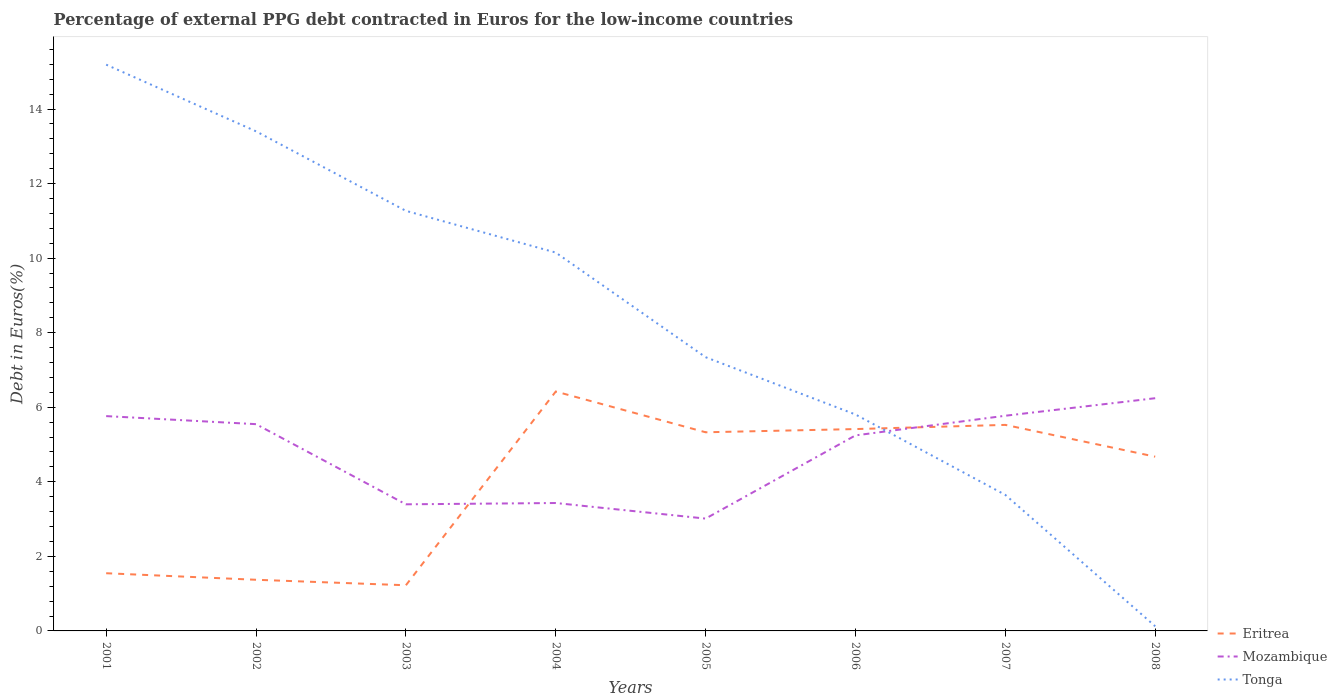Is the number of lines equal to the number of legend labels?
Your answer should be compact. Yes. Across all years, what is the maximum percentage of external PPG debt contracted in Euros in Tonga?
Your answer should be very brief. 0.12. What is the total percentage of external PPG debt contracted in Euros in Mozambique in the graph?
Your answer should be compact. -3.23. What is the difference between the highest and the second highest percentage of external PPG debt contracted in Euros in Tonga?
Make the answer very short. 15.07. Is the percentage of external PPG debt contracted in Euros in Tonga strictly greater than the percentage of external PPG debt contracted in Euros in Mozambique over the years?
Give a very brief answer. No. How many lines are there?
Make the answer very short. 3. What is the difference between two consecutive major ticks on the Y-axis?
Provide a succinct answer. 2. Are the values on the major ticks of Y-axis written in scientific E-notation?
Offer a very short reply. No. Does the graph contain any zero values?
Offer a very short reply. No. How many legend labels are there?
Provide a short and direct response. 3. How are the legend labels stacked?
Your answer should be compact. Vertical. What is the title of the graph?
Provide a short and direct response. Percentage of external PPG debt contracted in Euros for the low-income countries. Does "Serbia" appear as one of the legend labels in the graph?
Your answer should be compact. No. What is the label or title of the X-axis?
Your response must be concise. Years. What is the label or title of the Y-axis?
Your answer should be compact. Debt in Euros(%). What is the Debt in Euros(%) of Eritrea in 2001?
Keep it short and to the point. 1.55. What is the Debt in Euros(%) in Mozambique in 2001?
Make the answer very short. 5.76. What is the Debt in Euros(%) of Tonga in 2001?
Offer a very short reply. 15.19. What is the Debt in Euros(%) of Eritrea in 2002?
Give a very brief answer. 1.37. What is the Debt in Euros(%) of Mozambique in 2002?
Your answer should be compact. 5.55. What is the Debt in Euros(%) in Tonga in 2002?
Your answer should be compact. 13.4. What is the Debt in Euros(%) in Eritrea in 2003?
Ensure brevity in your answer.  1.23. What is the Debt in Euros(%) of Mozambique in 2003?
Keep it short and to the point. 3.4. What is the Debt in Euros(%) of Tonga in 2003?
Give a very brief answer. 11.27. What is the Debt in Euros(%) of Eritrea in 2004?
Offer a very short reply. 6.42. What is the Debt in Euros(%) in Mozambique in 2004?
Your response must be concise. 3.43. What is the Debt in Euros(%) of Tonga in 2004?
Provide a succinct answer. 10.15. What is the Debt in Euros(%) of Eritrea in 2005?
Make the answer very short. 5.33. What is the Debt in Euros(%) in Mozambique in 2005?
Give a very brief answer. 3.01. What is the Debt in Euros(%) of Tonga in 2005?
Your response must be concise. 7.34. What is the Debt in Euros(%) of Eritrea in 2006?
Make the answer very short. 5.41. What is the Debt in Euros(%) of Mozambique in 2006?
Your answer should be very brief. 5.25. What is the Debt in Euros(%) of Tonga in 2006?
Make the answer very short. 5.81. What is the Debt in Euros(%) of Eritrea in 2007?
Ensure brevity in your answer.  5.53. What is the Debt in Euros(%) in Mozambique in 2007?
Offer a very short reply. 5.77. What is the Debt in Euros(%) in Tonga in 2007?
Your response must be concise. 3.65. What is the Debt in Euros(%) in Eritrea in 2008?
Give a very brief answer. 4.67. What is the Debt in Euros(%) in Mozambique in 2008?
Keep it short and to the point. 6.24. What is the Debt in Euros(%) of Tonga in 2008?
Offer a very short reply. 0.12. Across all years, what is the maximum Debt in Euros(%) in Eritrea?
Your answer should be compact. 6.42. Across all years, what is the maximum Debt in Euros(%) in Mozambique?
Keep it short and to the point. 6.24. Across all years, what is the maximum Debt in Euros(%) of Tonga?
Your response must be concise. 15.19. Across all years, what is the minimum Debt in Euros(%) in Eritrea?
Your answer should be very brief. 1.23. Across all years, what is the minimum Debt in Euros(%) in Mozambique?
Give a very brief answer. 3.01. Across all years, what is the minimum Debt in Euros(%) in Tonga?
Ensure brevity in your answer.  0.12. What is the total Debt in Euros(%) of Eritrea in the graph?
Ensure brevity in your answer.  31.51. What is the total Debt in Euros(%) in Mozambique in the graph?
Make the answer very short. 38.41. What is the total Debt in Euros(%) in Tonga in the graph?
Ensure brevity in your answer.  66.93. What is the difference between the Debt in Euros(%) in Eritrea in 2001 and that in 2002?
Give a very brief answer. 0.18. What is the difference between the Debt in Euros(%) of Mozambique in 2001 and that in 2002?
Your answer should be compact. 0.22. What is the difference between the Debt in Euros(%) in Tonga in 2001 and that in 2002?
Provide a short and direct response. 1.79. What is the difference between the Debt in Euros(%) of Eritrea in 2001 and that in 2003?
Make the answer very short. 0.32. What is the difference between the Debt in Euros(%) of Mozambique in 2001 and that in 2003?
Give a very brief answer. 2.37. What is the difference between the Debt in Euros(%) of Tonga in 2001 and that in 2003?
Make the answer very short. 3.92. What is the difference between the Debt in Euros(%) in Eritrea in 2001 and that in 2004?
Ensure brevity in your answer.  -4.87. What is the difference between the Debt in Euros(%) in Mozambique in 2001 and that in 2004?
Your answer should be very brief. 2.33. What is the difference between the Debt in Euros(%) of Tonga in 2001 and that in 2004?
Your answer should be compact. 5.04. What is the difference between the Debt in Euros(%) in Eritrea in 2001 and that in 2005?
Provide a succinct answer. -3.78. What is the difference between the Debt in Euros(%) in Mozambique in 2001 and that in 2005?
Your answer should be very brief. 2.75. What is the difference between the Debt in Euros(%) of Tonga in 2001 and that in 2005?
Give a very brief answer. 7.85. What is the difference between the Debt in Euros(%) of Eritrea in 2001 and that in 2006?
Your answer should be very brief. -3.87. What is the difference between the Debt in Euros(%) in Mozambique in 2001 and that in 2006?
Your answer should be very brief. 0.52. What is the difference between the Debt in Euros(%) of Tonga in 2001 and that in 2006?
Provide a short and direct response. 9.38. What is the difference between the Debt in Euros(%) in Eritrea in 2001 and that in 2007?
Offer a terse response. -3.98. What is the difference between the Debt in Euros(%) in Mozambique in 2001 and that in 2007?
Your answer should be compact. -0.01. What is the difference between the Debt in Euros(%) in Tonga in 2001 and that in 2007?
Provide a succinct answer. 11.54. What is the difference between the Debt in Euros(%) in Eritrea in 2001 and that in 2008?
Offer a terse response. -3.13. What is the difference between the Debt in Euros(%) in Mozambique in 2001 and that in 2008?
Make the answer very short. -0.48. What is the difference between the Debt in Euros(%) in Tonga in 2001 and that in 2008?
Your answer should be very brief. 15.07. What is the difference between the Debt in Euros(%) of Eritrea in 2002 and that in 2003?
Your answer should be compact. 0.15. What is the difference between the Debt in Euros(%) of Mozambique in 2002 and that in 2003?
Make the answer very short. 2.15. What is the difference between the Debt in Euros(%) in Tonga in 2002 and that in 2003?
Your answer should be very brief. 2.13. What is the difference between the Debt in Euros(%) in Eritrea in 2002 and that in 2004?
Keep it short and to the point. -5.05. What is the difference between the Debt in Euros(%) in Mozambique in 2002 and that in 2004?
Offer a very short reply. 2.12. What is the difference between the Debt in Euros(%) in Tonga in 2002 and that in 2004?
Keep it short and to the point. 3.25. What is the difference between the Debt in Euros(%) of Eritrea in 2002 and that in 2005?
Offer a very short reply. -3.96. What is the difference between the Debt in Euros(%) in Mozambique in 2002 and that in 2005?
Your response must be concise. 2.53. What is the difference between the Debt in Euros(%) in Tonga in 2002 and that in 2005?
Your response must be concise. 6.06. What is the difference between the Debt in Euros(%) in Eritrea in 2002 and that in 2006?
Provide a short and direct response. -4.04. What is the difference between the Debt in Euros(%) in Mozambique in 2002 and that in 2006?
Give a very brief answer. 0.3. What is the difference between the Debt in Euros(%) of Tonga in 2002 and that in 2006?
Your answer should be compact. 7.6. What is the difference between the Debt in Euros(%) in Eritrea in 2002 and that in 2007?
Make the answer very short. -4.15. What is the difference between the Debt in Euros(%) of Mozambique in 2002 and that in 2007?
Provide a succinct answer. -0.23. What is the difference between the Debt in Euros(%) of Tonga in 2002 and that in 2007?
Make the answer very short. 9.75. What is the difference between the Debt in Euros(%) of Eritrea in 2002 and that in 2008?
Your answer should be very brief. -3.3. What is the difference between the Debt in Euros(%) of Mozambique in 2002 and that in 2008?
Ensure brevity in your answer.  -0.7. What is the difference between the Debt in Euros(%) of Tonga in 2002 and that in 2008?
Ensure brevity in your answer.  13.28. What is the difference between the Debt in Euros(%) in Eritrea in 2003 and that in 2004?
Your answer should be very brief. -5.2. What is the difference between the Debt in Euros(%) of Mozambique in 2003 and that in 2004?
Give a very brief answer. -0.04. What is the difference between the Debt in Euros(%) in Tonga in 2003 and that in 2004?
Your answer should be compact. 1.12. What is the difference between the Debt in Euros(%) in Eritrea in 2003 and that in 2005?
Provide a short and direct response. -4.1. What is the difference between the Debt in Euros(%) in Mozambique in 2003 and that in 2005?
Your answer should be compact. 0.38. What is the difference between the Debt in Euros(%) of Tonga in 2003 and that in 2005?
Give a very brief answer. 3.93. What is the difference between the Debt in Euros(%) in Eritrea in 2003 and that in 2006?
Ensure brevity in your answer.  -4.19. What is the difference between the Debt in Euros(%) in Mozambique in 2003 and that in 2006?
Give a very brief answer. -1.85. What is the difference between the Debt in Euros(%) in Tonga in 2003 and that in 2006?
Keep it short and to the point. 5.46. What is the difference between the Debt in Euros(%) in Eritrea in 2003 and that in 2007?
Give a very brief answer. -4.3. What is the difference between the Debt in Euros(%) in Mozambique in 2003 and that in 2007?
Give a very brief answer. -2.38. What is the difference between the Debt in Euros(%) of Tonga in 2003 and that in 2007?
Give a very brief answer. 7.62. What is the difference between the Debt in Euros(%) of Eritrea in 2003 and that in 2008?
Provide a succinct answer. -3.45. What is the difference between the Debt in Euros(%) in Mozambique in 2003 and that in 2008?
Offer a terse response. -2.85. What is the difference between the Debt in Euros(%) of Tonga in 2003 and that in 2008?
Make the answer very short. 11.14. What is the difference between the Debt in Euros(%) of Eritrea in 2004 and that in 2005?
Ensure brevity in your answer.  1.09. What is the difference between the Debt in Euros(%) of Mozambique in 2004 and that in 2005?
Give a very brief answer. 0.42. What is the difference between the Debt in Euros(%) of Tonga in 2004 and that in 2005?
Provide a short and direct response. 2.81. What is the difference between the Debt in Euros(%) of Mozambique in 2004 and that in 2006?
Ensure brevity in your answer.  -1.81. What is the difference between the Debt in Euros(%) in Tonga in 2004 and that in 2006?
Keep it short and to the point. 4.34. What is the difference between the Debt in Euros(%) of Eritrea in 2004 and that in 2007?
Make the answer very short. 0.9. What is the difference between the Debt in Euros(%) in Mozambique in 2004 and that in 2007?
Make the answer very short. -2.34. What is the difference between the Debt in Euros(%) in Tonga in 2004 and that in 2007?
Make the answer very short. 6.5. What is the difference between the Debt in Euros(%) in Eritrea in 2004 and that in 2008?
Offer a terse response. 1.75. What is the difference between the Debt in Euros(%) in Mozambique in 2004 and that in 2008?
Keep it short and to the point. -2.81. What is the difference between the Debt in Euros(%) of Tonga in 2004 and that in 2008?
Provide a short and direct response. 10.02. What is the difference between the Debt in Euros(%) in Eritrea in 2005 and that in 2006?
Make the answer very short. -0.09. What is the difference between the Debt in Euros(%) in Mozambique in 2005 and that in 2006?
Ensure brevity in your answer.  -2.23. What is the difference between the Debt in Euros(%) of Tonga in 2005 and that in 2006?
Provide a short and direct response. 1.54. What is the difference between the Debt in Euros(%) of Eritrea in 2005 and that in 2007?
Your response must be concise. -0.2. What is the difference between the Debt in Euros(%) of Mozambique in 2005 and that in 2007?
Give a very brief answer. -2.76. What is the difference between the Debt in Euros(%) of Tonga in 2005 and that in 2007?
Your answer should be very brief. 3.69. What is the difference between the Debt in Euros(%) in Eritrea in 2005 and that in 2008?
Give a very brief answer. 0.65. What is the difference between the Debt in Euros(%) of Mozambique in 2005 and that in 2008?
Keep it short and to the point. -3.23. What is the difference between the Debt in Euros(%) in Tonga in 2005 and that in 2008?
Offer a very short reply. 7.22. What is the difference between the Debt in Euros(%) of Eritrea in 2006 and that in 2007?
Offer a very short reply. -0.11. What is the difference between the Debt in Euros(%) in Mozambique in 2006 and that in 2007?
Provide a succinct answer. -0.53. What is the difference between the Debt in Euros(%) of Tonga in 2006 and that in 2007?
Keep it short and to the point. 2.16. What is the difference between the Debt in Euros(%) in Eritrea in 2006 and that in 2008?
Your response must be concise. 0.74. What is the difference between the Debt in Euros(%) in Mozambique in 2006 and that in 2008?
Provide a succinct answer. -1. What is the difference between the Debt in Euros(%) of Tonga in 2006 and that in 2008?
Your response must be concise. 5.68. What is the difference between the Debt in Euros(%) of Eritrea in 2007 and that in 2008?
Make the answer very short. 0.85. What is the difference between the Debt in Euros(%) of Mozambique in 2007 and that in 2008?
Keep it short and to the point. -0.47. What is the difference between the Debt in Euros(%) in Tonga in 2007 and that in 2008?
Give a very brief answer. 3.52. What is the difference between the Debt in Euros(%) in Eritrea in 2001 and the Debt in Euros(%) in Mozambique in 2002?
Provide a short and direct response. -4. What is the difference between the Debt in Euros(%) of Eritrea in 2001 and the Debt in Euros(%) of Tonga in 2002?
Offer a terse response. -11.85. What is the difference between the Debt in Euros(%) in Mozambique in 2001 and the Debt in Euros(%) in Tonga in 2002?
Ensure brevity in your answer.  -7.64. What is the difference between the Debt in Euros(%) of Eritrea in 2001 and the Debt in Euros(%) of Mozambique in 2003?
Your answer should be very brief. -1.85. What is the difference between the Debt in Euros(%) in Eritrea in 2001 and the Debt in Euros(%) in Tonga in 2003?
Make the answer very short. -9.72. What is the difference between the Debt in Euros(%) in Mozambique in 2001 and the Debt in Euros(%) in Tonga in 2003?
Ensure brevity in your answer.  -5.51. What is the difference between the Debt in Euros(%) of Eritrea in 2001 and the Debt in Euros(%) of Mozambique in 2004?
Provide a succinct answer. -1.88. What is the difference between the Debt in Euros(%) in Eritrea in 2001 and the Debt in Euros(%) in Tonga in 2004?
Offer a terse response. -8.6. What is the difference between the Debt in Euros(%) of Mozambique in 2001 and the Debt in Euros(%) of Tonga in 2004?
Your response must be concise. -4.39. What is the difference between the Debt in Euros(%) of Eritrea in 2001 and the Debt in Euros(%) of Mozambique in 2005?
Offer a terse response. -1.47. What is the difference between the Debt in Euros(%) of Eritrea in 2001 and the Debt in Euros(%) of Tonga in 2005?
Your answer should be very brief. -5.8. What is the difference between the Debt in Euros(%) in Mozambique in 2001 and the Debt in Euros(%) in Tonga in 2005?
Offer a very short reply. -1.58. What is the difference between the Debt in Euros(%) in Eritrea in 2001 and the Debt in Euros(%) in Mozambique in 2006?
Offer a very short reply. -3.7. What is the difference between the Debt in Euros(%) of Eritrea in 2001 and the Debt in Euros(%) of Tonga in 2006?
Your answer should be very brief. -4.26. What is the difference between the Debt in Euros(%) of Mozambique in 2001 and the Debt in Euros(%) of Tonga in 2006?
Ensure brevity in your answer.  -0.04. What is the difference between the Debt in Euros(%) of Eritrea in 2001 and the Debt in Euros(%) of Mozambique in 2007?
Offer a very short reply. -4.23. What is the difference between the Debt in Euros(%) of Eritrea in 2001 and the Debt in Euros(%) of Tonga in 2007?
Ensure brevity in your answer.  -2.1. What is the difference between the Debt in Euros(%) in Mozambique in 2001 and the Debt in Euros(%) in Tonga in 2007?
Your response must be concise. 2.11. What is the difference between the Debt in Euros(%) in Eritrea in 2001 and the Debt in Euros(%) in Mozambique in 2008?
Offer a terse response. -4.7. What is the difference between the Debt in Euros(%) in Eritrea in 2001 and the Debt in Euros(%) in Tonga in 2008?
Your response must be concise. 1.42. What is the difference between the Debt in Euros(%) in Mozambique in 2001 and the Debt in Euros(%) in Tonga in 2008?
Provide a succinct answer. 5.64. What is the difference between the Debt in Euros(%) of Eritrea in 2002 and the Debt in Euros(%) of Mozambique in 2003?
Your answer should be very brief. -2.02. What is the difference between the Debt in Euros(%) of Eritrea in 2002 and the Debt in Euros(%) of Tonga in 2003?
Offer a terse response. -9.9. What is the difference between the Debt in Euros(%) in Mozambique in 2002 and the Debt in Euros(%) in Tonga in 2003?
Offer a terse response. -5.72. What is the difference between the Debt in Euros(%) in Eritrea in 2002 and the Debt in Euros(%) in Mozambique in 2004?
Your response must be concise. -2.06. What is the difference between the Debt in Euros(%) in Eritrea in 2002 and the Debt in Euros(%) in Tonga in 2004?
Keep it short and to the point. -8.78. What is the difference between the Debt in Euros(%) in Mozambique in 2002 and the Debt in Euros(%) in Tonga in 2004?
Offer a very short reply. -4.6. What is the difference between the Debt in Euros(%) of Eritrea in 2002 and the Debt in Euros(%) of Mozambique in 2005?
Your response must be concise. -1.64. What is the difference between the Debt in Euros(%) in Eritrea in 2002 and the Debt in Euros(%) in Tonga in 2005?
Ensure brevity in your answer.  -5.97. What is the difference between the Debt in Euros(%) of Mozambique in 2002 and the Debt in Euros(%) of Tonga in 2005?
Offer a very short reply. -1.8. What is the difference between the Debt in Euros(%) of Eritrea in 2002 and the Debt in Euros(%) of Mozambique in 2006?
Your answer should be very brief. -3.87. What is the difference between the Debt in Euros(%) of Eritrea in 2002 and the Debt in Euros(%) of Tonga in 2006?
Provide a short and direct response. -4.43. What is the difference between the Debt in Euros(%) in Mozambique in 2002 and the Debt in Euros(%) in Tonga in 2006?
Your answer should be compact. -0.26. What is the difference between the Debt in Euros(%) of Eritrea in 2002 and the Debt in Euros(%) of Mozambique in 2007?
Give a very brief answer. -4.4. What is the difference between the Debt in Euros(%) of Eritrea in 2002 and the Debt in Euros(%) of Tonga in 2007?
Offer a very short reply. -2.28. What is the difference between the Debt in Euros(%) of Mozambique in 2002 and the Debt in Euros(%) of Tonga in 2007?
Keep it short and to the point. 1.9. What is the difference between the Debt in Euros(%) of Eritrea in 2002 and the Debt in Euros(%) of Mozambique in 2008?
Your answer should be compact. -4.87. What is the difference between the Debt in Euros(%) in Eritrea in 2002 and the Debt in Euros(%) in Tonga in 2008?
Offer a terse response. 1.25. What is the difference between the Debt in Euros(%) of Mozambique in 2002 and the Debt in Euros(%) of Tonga in 2008?
Offer a terse response. 5.42. What is the difference between the Debt in Euros(%) in Eritrea in 2003 and the Debt in Euros(%) in Mozambique in 2004?
Provide a short and direct response. -2.21. What is the difference between the Debt in Euros(%) in Eritrea in 2003 and the Debt in Euros(%) in Tonga in 2004?
Provide a short and direct response. -8.92. What is the difference between the Debt in Euros(%) in Mozambique in 2003 and the Debt in Euros(%) in Tonga in 2004?
Give a very brief answer. -6.75. What is the difference between the Debt in Euros(%) in Eritrea in 2003 and the Debt in Euros(%) in Mozambique in 2005?
Provide a short and direct response. -1.79. What is the difference between the Debt in Euros(%) of Eritrea in 2003 and the Debt in Euros(%) of Tonga in 2005?
Keep it short and to the point. -6.12. What is the difference between the Debt in Euros(%) in Mozambique in 2003 and the Debt in Euros(%) in Tonga in 2005?
Provide a succinct answer. -3.95. What is the difference between the Debt in Euros(%) of Eritrea in 2003 and the Debt in Euros(%) of Mozambique in 2006?
Your answer should be compact. -4.02. What is the difference between the Debt in Euros(%) in Eritrea in 2003 and the Debt in Euros(%) in Tonga in 2006?
Give a very brief answer. -4.58. What is the difference between the Debt in Euros(%) in Mozambique in 2003 and the Debt in Euros(%) in Tonga in 2006?
Provide a succinct answer. -2.41. What is the difference between the Debt in Euros(%) in Eritrea in 2003 and the Debt in Euros(%) in Mozambique in 2007?
Keep it short and to the point. -4.55. What is the difference between the Debt in Euros(%) of Eritrea in 2003 and the Debt in Euros(%) of Tonga in 2007?
Your answer should be compact. -2.42. What is the difference between the Debt in Euros(%) of Mozambique in 2003 and the Debt in Euros(%) of Tonga in 2007?
Provide a short and direct response. -0.25. What is the difference between the Debt in Euros(%) of Eritrea in 2003 and the Debt in Euros(%) of Mozambique in 2008?
Your answer should be very brief. -5.02. What is the difference between the Debt in Euros(%) of Eritrea in 2003 and the Debt in Euros(%) of Tonga in 2008?
Offer a terse response. 1.1. What is the difference between the Debt in Euros(%) in Mozambique in 2003 and the Debt in Euros(%) in Tonga in 2008?
Offer a very short reply. 3.27. What is the difference between the Debt in Euros(%) of Eritrea in 2004 and the Debt in Euros(%) of Mozambique in 2005?
Give a very brief answer. 3.41. What is the difference between the Debt in Euros(%) of Eritrea in 2004 and the Debt in Euros(%) of Tonga in 2005?
Your response must be concise. -0.92. What is the difference between the Debt in Euros(%) of Mozambique in 2004 and the Debt in Euros(%) of Tonga in 2005?
Give a very brief answer. -3.91. What is the difference between the Debt in Euros(%) in Eritrea in 2004 and the Debt in Euros(%) in Mozambique in 2006?
Your answer should be compact. 1.18. What is the difference between the Debt in Euros(%) in Eritrea in 2004 and the Debt in Euros(%) in Tonga in 2006?
Give a very brief answer. 0.62. What is the difference between the Debt in Euros(%) in Mozambique in 2004 and the Debt in Euros(%) in Tonga in 2006?
Give a very brief answer. -2.37. What is the difference between the Debt in Euros(%) in Eritrea in 2004 and the Debt in Euros(%) in Mozambique in 2007?
Keep it short and to the point. 0.65. What is the difference between the Debt in Euros(%) of Eritrea in 2004 and the Debt in Euros(%) of Tonga in 2007?
Keep it short and to the point. 2.77. What is the difference between the Debt in Euros(%) in Mozambique in 2004 and the Debt in Euros(%) in Tonga in 2007?
Offer a very short reply. -0.22. What is the difference between the Debt in Euros(%) in Eritrea in 2004 and the Debt in Euros(%) in Mozambique in 2008?
Your response must be concise. 0.18. What is the difference between the Debt in Euros(%) in Eritrea in 2004 and the Debt in Euros(%) in Tonga in 2008?
Your response must be concise. 6.3. What is the difference between the Debt in Euros(%) in Mozambique in 2004 and the Debt in Euros(%) in Tonga in 2008?
Your answer should be very brief. 3.31. What is the difference between the Debt in Euros(%) of Eritrea in 2005 and the Debt in Euros(%) of Mozambique in 2006?
Your response must be concise. 0.08. What is the difference between the Debt in Euros(%) of Eritrea in 2005 and the Debt in Euros(%) of Tonga in 2006?
Keep it short and to the point. -0.48. What is the difference between the Debt in Euros(%) in Mozambique in 2005 and the Debt in Euros(%) in Tonga in 2006?
Offer a very short reply. -2.79. What is the difference between the Debt in Euros(%) of Eritrea in 2005 and the Debt in Euros(%) of Mozambique in 2007?
Your answer should be very brief. -0.44. What is the difference between the Debt in Euros(%) of Eritrea in 2005 and the Debt in Euros(%) of Tonga in 2007?
Ensure brevity in your answer.  1.68. What is the difference between the Debt in Euros(%) of Mozambique in 2005 and the Debt in Euros(%) of Tonga in 2007?
Your response must be concise. -0.64. What is the difference between the Debt in Euros(%) in Eritrea in 2005 and the Debt in Euros(%) in Mozambique in 2008?
Provide a succinct answer. -0.91. What is the difference between the Debt in Euros(%) of Eritrea in 2005 and the Debt in Euros(%) of Tonga in 2008?
Offer a terse response. 5.2. What is the difference between the Debt in Euros(%) of Mozambique in 2005 and the Debt in Euros(%) of Tonga in 2008?
Provide a succinct answer. 2.89. What is the difference between the Debt in Euros(%) in Eritrea in 2006 and the Debt in Euros(%) in Mozambique in 2007?
Your answer should be compact. -0.36. What is the difference between the Debt in Euros(%) of Eritrea in 2006 and the Debt in Euros(%) of Tonga in 2007?
Ensure brevity in your answer.  1.77. What is the difference between the Debt in Euros(%) of Mozambique in 2006 and the Debt in Euros(%) of Tonga in 2007?
Provide a succinct answer. 1.6. What is the difference between the Debt in Euros(%) of Eritrea in 2006 and the Debt in Euros(%) of Mozambique in 2008?
Your response must be concise. -0.83. What is the difference between the Debt in Euros(%) of Eritrea in 2006 and the Debt in Euros(%) of Tonga in 2008?
Keep it short and to the point. 5.29. What is the difference between the Debt in Euros(%) in Mozambique in 2006 and the Debt in Euros(%) in Tonga in 2008?
Make the answer very short. 5.12. What is the difference between the Debt in Euros(%) in Eritrea in 2007 and the Debt in Euros(%) in Mozambique in 2008?
Keep it short and to the point. -0.72. What is the difference between the Debt in Euros(%) in Eritrea in 2007 and the Debt in Euros(%) in Tonga in 2008?
Provide a succinct answer. 5.4. What is the difference between the Debt in Euros(%) in Mozambique in 2007 and the Debt in Euros(%) in Tonga in 2008?
Ensure brevity in your answer.  5.65. What is the average Debt in Euros(%) in Eritrea per year?
Your response must be concise. 3.94. What is the average Debt in Euros(%) of Mozambique per year?
Offer a very short reply. 4.8. What is the average Debt in Euros(%) of Tonga per year?
Offer a terse response. 8.37. In the year 2001, what is the difference between the Debt in Euros(%) of Eritrea and Debt in Euros(%) of Mozambique?
Your response must be concise. -4.21. In the year 2001, what is the difference between the Debt in Euros(%) of Eritrea and Debt in Euros(%) of Tonga?
Offer a very short reply. -13.64. In the year 2001, what is the difference between the Debt in Euros(%) in Mozambique and Debt in Euros(%) in Tonga?
Offer a very short reply. -9.43. In the year 2002, what is the difference between the Debt in Euros(%) in Eritrea and Debt in Euros(%) in Mozambique?
Ensure brevity in your answer.  -4.17. In the year 2002, what is the difference between the Debt in Euros(%) in Eritrea and Debt in Euros(%) in Tonga?
Offer a terse response. -12.03. In the year 2002, what is the difference between the Debt in Euros(%) of Mozambique and Debt in Euros(%) of Tonga?
Your response must be concise. -7.86. In the year 2003, what is the difference between the Debt in Euros(%) of Eritrea and Debt in Euros(%) of Mozambique?
Offer a very short reply. -2.17. In the year 2003, what is the difference between the Debt in Euros(%) in Eritrea and Debt in Euros(%) in Tonga?
Ensure brevity in your answer.  -10.04. In the year 2003, what is the difference between the Debt in Euros(%) in Mozambique and Debt in Euros(%) in Tonga?
Your response must be concise. -7.87. In the year 2004, what is the difference between the Debt in Euros(%) of Eritrea and Debt in Euros(%) of Mozambique?
Your answer should be compact. 2.99. In the year 2004, what is the difference between the Debt in Euros(%) of Eritrea and Debt in Euros(%) of Tonga?
Keep it short and to the point. -3.73. In the year 2004, what is the difference between the Debt in Euros(%) of Mozambique and Debt in Euros(%) of Tonga?
Offer a very short reply. -6.72. In the year 2005, what is the difference between the Debt in Euros(%) of Eritrea and Debt in Euros(%) of Mozambique?
Your response must be concise. 2.32. In the year 2005, what is the difference between the Debt in Euros(%) of Eritrea and Debt in Euros(%) of Tonga?
Give a very brief answer. -2.01. In the year 2005, what is the difference between the Debt in Euros(%) of Mozambique and Debt in Euros(%) of Tonga?
Ensure brevity in your answer.  -4.33. In the year 2006, what is the difference between the Debt in Euros(%) in Eritrea and Debt in Euros(%) in Mozambique?
Your answer should be compact. 0.17. In the year 2006, what is the difference between the Debt in Euros(%) of Eritrea and Debt in Euros(%) of Tonga?
Your response must be concise. -0.39. In the year 2006, what is the difference between the Debt in Euros(%) in Mozambique and Debt in Euros(%) in Tonga?
Offer a terse response. -0.56. In the year 2007, what is the difference between the Debt in Euros(%) in Eritrea and Debt in Euros(%) in Mozambique?
Provide a succinct answer. -0.25. In the year 2007, what is the difference between the Debt in Euros(%) in Eritrea and Debt in Euros(%) in Tonga?
Give a very brief answer. 1.88. In the year 2007, what is the difference between the Debt in Euros(%) of Mozambique and Debt in Euros(%) of Tonga?
Keep it short and to the point. 2.12. In the year 2008, what is the difference between the Debt in Euros(%) of Eritrea and Debt in Euros(%) of Mozambique?
Give a very brief answer. -1.57. In the year 2008, what is the difference between the Debt in Euros(%) of Eritrea and Debt in Euros(%) of Tonga?
Offer a very short reply. 4.55. In the year 2008, what is the difference between the Debt in Euros(%) in Mozambique and Debt in Euros(%) in Tonga?
Your response must be concise. 6.12. What is the ratio of the Debt in Euros(%) in Eritrea in 2001 to that in 2002?
Offer a terse response. 1.13. What is the ratio of the Debt in Euros(%) of Mozambique in 2001 to that in 2002?
Give a very brief answer. 1.04. What is the ratio of the Debt in Euros(%) of Tonga in 2001 to that in 2002?
Make the answer very short. 1.13. What is the ratio of the Debt in Euros(%) in Eritrea in 2001 to that in 2003?
Your answer should be compact. 1.26. What is the ratio of the Debt in Euros(%) in Mozambique in 2001 to that in 2003?
Your answer should be compact. 1.7. What is the ratio of the Debt in Euros(%) of Tonga in 2001 to that in 2003?
Keep it short and to the point. 1.35. What is the ratio of the Debt in Euros(%) in Eritrea in 2001 to that in 2004?
Offer a terse response. 0.24. What is the ratio of the Debt in Euros(%) in Mozambique in 2001 to that in 2004?
Make the answer very short. 1.68. What is the ratio of the Debt in Euros(%) of Tonga in 2001 to that in 2004?
Offer a terse response. 1.5. What is the ratio of the Debt in Euros(%) of Eritrea in 2001 to that in 2005?
Provide a short and direct response. 0.29. What is the ratio of the Debt in Euros(%) in Mozambique in 2001 to that in 2005?
Give a very brief answer. 1.91. What is the ratio of the Debt in Euros(%) of Tonga in 2001 to that in 2005?
Provide a short and direct response. 2.07. What is the ratio of the Debt in Euros(%) of Eritrea in 2001 to that in 2006?
Your answer should be very brief. 0.29. What is the ratio of the Debt in Euros(%) of Mozambique in 2001 to that in 2006?
Make the answer very short. 1.1. What is the ratio of the Debt in Euros(%) of Tonga in 2001 to that in 2006?
Offer a terse response. 2.62. What is the ratio of the Debt in Euros(%) in Eritrea in 2001 to that in 2007?
Keep it short and to the point. 0.28. What is the ratio of the Debt in Euros(%) of Mozambique in 2001 to that in 2007?
Make the answer very short. 1. What is the ratio of the Debt in Euros(%) in Tonga in 2001 to that in 2007?
Make the answer very short. 4.16. What is the ratio of the Debt in Euros(%) of Eritrea in 2001 to that in 2008?
Provide a succinct answer. 0.33. What is the ratio of the Debt in Euros(%) in Mozambique in 2001 to that in 2008?
Offer a very short reply. 0.92. What is the ratio of the Debt in Euros(%) of Tonga in 2001 to that in 2008?
Your response must be concise. 121.62. What is the ratio of the Debt in Euros(%) of Eritrea in 2002 to that in 2003?
Your response must be concise. 1.12. What is the ratio of the Debt in Euros(%) of Mozambique in 2002 to that in 2003?
Your response must be concise. 1.63. What is the ratio of the Debt in Euros(%) in Tonga in 2002 to that in 2003?
Provide a short and direct response. 1.19. What is the ratio of the Debt in Euros(%) of Eritrea in 2002 to that in 2004?
Ensure brevity in your answer.  0.21. What is the ratio of the Debt in Euros(%) of Mozambique in 2002 to that in 2004?
Give a very brief answer. 1.62. What is the ratio of the Debt in Euros(%) of Tonga in 2002 to that in 2004?
Keep it short and to the point. 1.32. What is the ratio of the Debt in Euros(%) in Eritrea in 2002 to that in 2005?
Your answer should be very brief. 0.26. What is the ratio of the Debt in Euros(%) of Mozambique in 2002 to that in 2005?
Offer a very short reply. 1.84. What is the ratio of the Debt in Euros(%) of Tonga in 2002 to that in 2005?
Provide a short and direct response. 1.83. What is the ratio of the Debt in Euros(%) in Eritrea in 2002 to that in 2006?
Your answer should be very brief. 0.25. What is the ratio of the Debt in Euros(%) in Mozambique in 2002 to that in 2006?
Offer a very short reply. 1.06. What is the ratio of the Debt in Euros(%) in Tonga in 2002 to that in 2006?
Provide a succinct answer. 2.31. What is the ratio of the Debt in Euros(%) in Eritrea in 2002 to that in 2007?
Your response must be concise. 0.25. What is the ratio of the Debt in Euros(%) in Mozambique in 2002 to that in 2007?
Provide a succinct answer. 0.96. What is the ratio of the Debt in Euros(%) of Tonga in 2002 to that in 2007?
Provide a short and direct response. 3.67. What is the ratio of the Debt in Euros(%) in Eritrea in 2002 to that in 2008?
Your response must be concise. 0.29. What is the ratio of the Debt in Euros(%) in Mozambique in 2002 to that in 2008?
Offer a terse response. 0.89. What is the ratio of the Debt in Euros(%) in Tonga in 2002 to that in 2008?
Ensure brevity in your answer.  107.3. What is the ratio of the Debt in Euros(%) of Eritrea in 2003 to that in 2004?
Your answer should be very brief. 0.19. What is the ratio of the Debt in Euros(%) in Tonga in 2003 to that in 2004?
Your answer should be compact. 1.11. What is the ratio of the Debt in Euros(%) of Eritrea in 2003 to that in 2005?
Your answer should be very brief. 0.23. What is the ratio of the Debt in Euros(%) in Mozambique in 2003 to that in 2005?
Make the answer very short. 1.13. What is the ratio of the Debt in Euros(%) in Tonga in 2003 to that in 2005?
Make the answer very short. 1.53. What is the ratio of the Debt in Euros(%) of Eritrea in 2003 to that in 2006?
Keep it short and to the point. 0.23. What is the ratio of the Debt in Euros(%) of Mozambique in 2003 to that in 2006?
Offer a very short reply. 0.65. What is the ratio of the Debt in Euros(%) of Tonga in 2003 to that in 2006?
Make the answer very short. 1.94. What is the ratio of the Debt in Euros(%) of Eritrea in 2003 to that in 2007?
Your answer should be very brief. 0.22. What is the ratio of the Debt in Euros(%) in Mozambique in 2003 to that in 2007?
Provide a short and direct response. 0.59. What is the ratio of the Debt in Euros(%) in Tonga in 2003 to that in 2007?
Your answer should be compact. 3.09. What is the ratio of the Debt in Euros(%) in Eritrea in 2003 to that in 2008?
Give a very brief answer. 0.26. What is the ratio of the Debt in Euros(%) in Mozambique in 2003 to that in 2008?
Ensure brevity in your answer.  0.54. What is the ratio of the Debt in Euros(%) in Tonga in 2003 to that in 2008?
Keep it short and to the point. 90.22. What is the ratio of the Debt in Euros(%) in Eritrea in 2004 to that in 2005?
Offer a very short reply. 1.21. What is the ratio of the Debt in Euros(%) in Mozambique in 2004 to that in 2005?
Your answer should be compact. 1.14. What is the ratio of the Debt in Euros(%) in Tonga in 2004 to that in 2005?
Give a very brief answer. 1.38. What is the ratio of the Debt in Euros(%) of Eritrea in 2004 to that in 2006?
Provide a short and direct response. 1.19. What is the ratio of the Debt in Euros(%) in Mozambique in 2004 to that in 2006?
Provide a succinct answer. 0.65. What is the ratio of the Debt in Euros(%) of Tonga in 2004 to that in 2006?
Provide a succinct answer. 1.75. What is the ratio of the Debt in Euros(%) in Eritrea in 2004 to that in 2007?
Offer a very short reply. 1.16. What is the ratio of the Debt in Euros(%) in Mozambique in 2004 to that in 2007?
Give a very brief answer. 0.59. What is the ratio of the Debt in Euros(%) in Tonga in 2004 to that in 2007?
Your response must be concise. 2.78. What is the ratio of the Debt in Euros(%) of Eritrea in 2004 to that in 2008?
Your answer should be compact. 1.37. What is the ratio of the Debt in Euros(%) of Mozambique in 2004 to that in 2008?
Provide a succinct answer. 0.55. What is the ratio of the Debt in Euros(%) in Tonga in 2004 to that in 2008?
Provide a succinct answer. 81.26. What is the ratio of the Debt in Euros(%) in Eritrea in 2005 to that in 2006?
Ensure brevity in your answer.  0.98. What is the ratio of the Debt in Euros(%) in Mozambique in 2005 to that in 2006?
Provide a short and direct response. 0.57. What is the ratio of the Debt in Euros(%) of Tonga in 2005 to that in 2006?
Offer a very short reply. 1.26. What is the ratio of the Debt in Euros(%) of Eritrea in 2005 to that in 2007?
Provide a succinct answer. 0.96. What is the ratio of the Debt in Euros(%) in Mozambique in 2005 to that in 2007?
Ensure brevity in your answer.  0.52. What is the ratio of the Debt in Euros(%) of Tonga in 2005 to that in 2007?
Your answer should be compact. 2.01. What is the ratio of the Debt in Euros(%) in Eritrea in 2005 to that in 2008?
Your answer should be very brief. 1.14. What is the ratio of the Debt in Euros(%) in Mozambique in 2005 to that in 2008?
Offer a terse response. 0.48. What is the ratio of the Debt in Euros(%) of Tonga in 2005 to that in 2008?
Ensure brevity in your answer.  58.79. What is the ratio of the Debt in Euros(%) in Eritrea in 2006 to that in 2007?
Keep it short and to the point. 0.98. What is the ratio of the Debt in Euros(%) of Mozambique in 2006 to that in 2007?
Keep it short and to the point. 0.91. What is the ratio of the Debt in Euros(%) in Tonga in 2006 to that in 2007?
Your answer should be compact. 1.59. What is the ratio of the Debt in Euros(%) in Eritrea in 2006 to that in 2008?
Provide a succinct answer. 1.16. What is the ratio of the Debt in Euros(%) in Mozambique in 2006 to that in 2008?
Provide a short and direct response. 0.84. What is the ratio of the Debt in Euros(%) in Tonga in 2006 to that in 2008?
Ensure brevity in your answer.  46.49. What is the ratio of the Debt in Euros(%) of Eritrea in 2007 to that in 2008?
Make the answer very short. 1.18. What is the ratio of the Debt in Euros(%) of Mozambique in 2007 to that in 2008?
Ensure brevity in your answer.  0.92. What is the ratio of the Debt in Euros(%) in Tonga in 2007 to that in 2008?
Offer a terse response. 29.21. What is the difference between the highest and the second highest Debt in Euros(%) of Eritrea?
Offer a very short reply. 0.9. What is the difference between the highest and the second highest Debt in Euros(%) in Mozambique?
Make the answer very short. 0.47. What is the difference between the highest and the second highest Debt in Euros(%) of Tonga?
Provide a succinct answer. 1.79. What is the difference between the highest and the lowest Debt in Euros(%) in Eritrea?
Your answer should be very brief. 5.2. What is the difference between the highest and the lowest Debt in Euros(%) of Mozambique?
Your response must be concise. 3.23. What is the difference between the highest and the lowest Debt in Euros(%) in Tonga?
Keep it short and to the point. 15.07. 